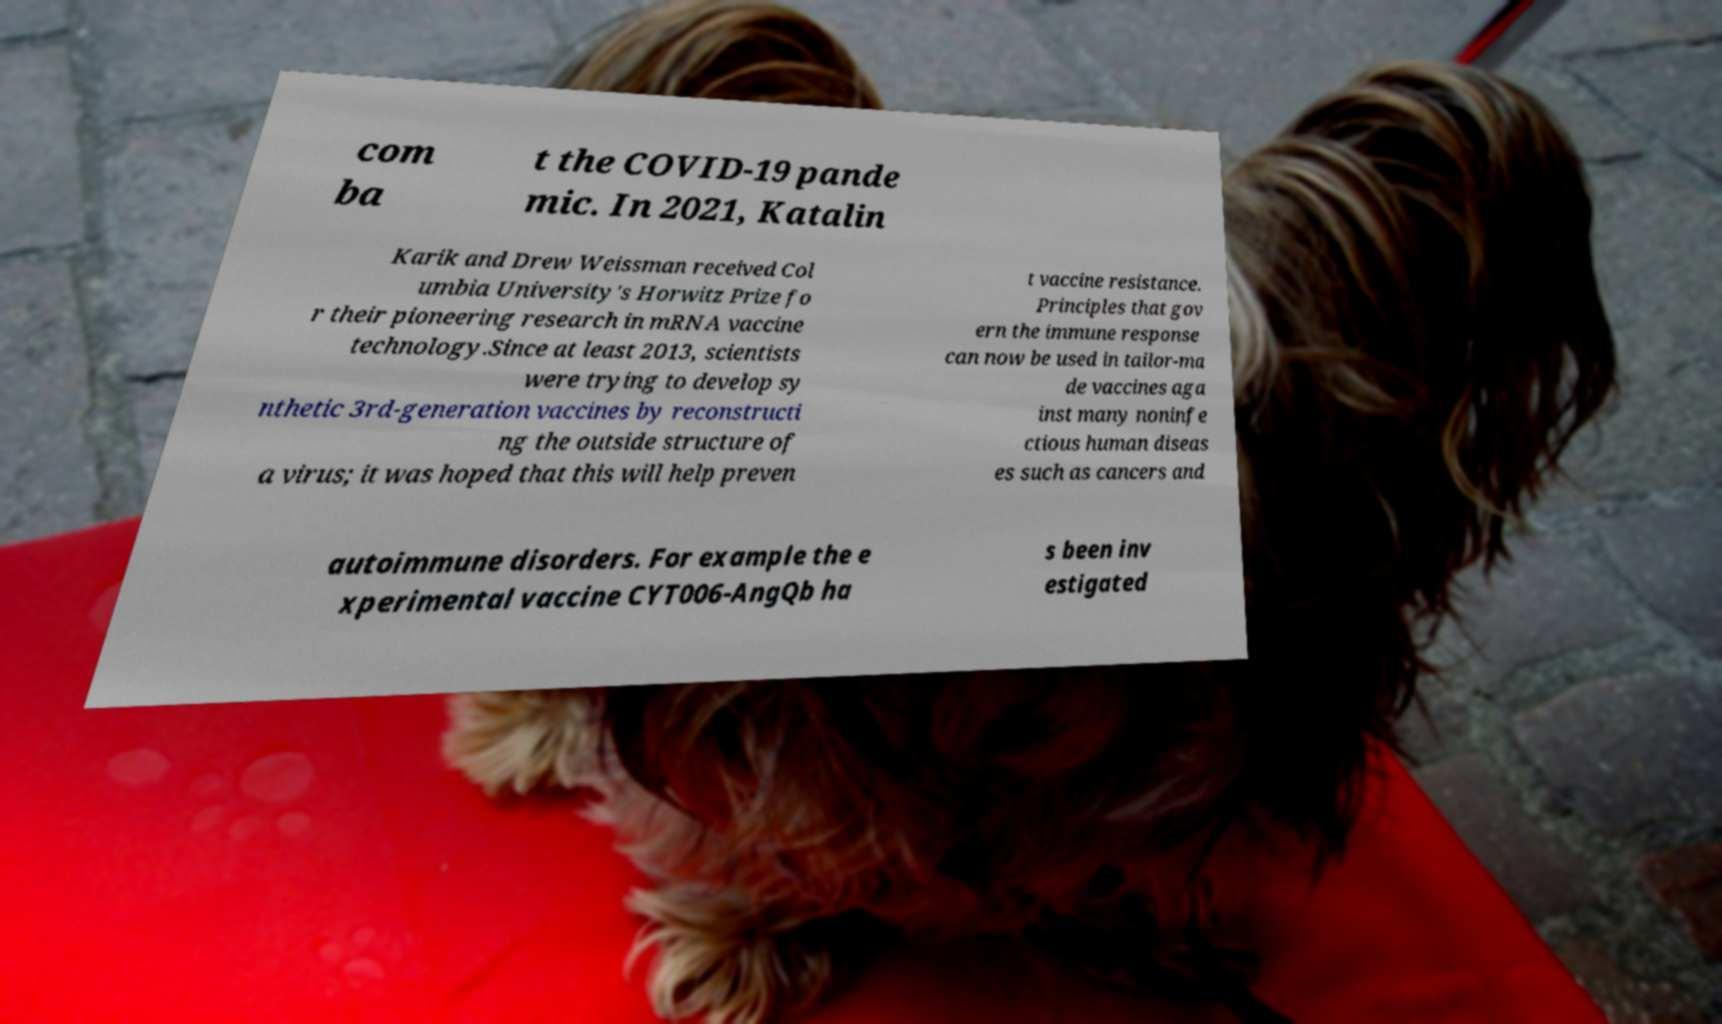Please identify and transcribe the text found in this image. com ba t the COVID-19 pande mic. In 2021, Katalin Karik and Drew Weissman received Col umbia University's Horwitz Prize fo r their pioneering research in mRNA vaccine technology.Since at least 2013, scientists were trying to develop sy nthetic 3rd-generation vaccines by reconstructi ng the outside structure of a virus; it was hoped that this will help preven t vaccine resistance. Principles that gov ern the immune response can now be used in tailor-ma de vaccines aga inst many noninfe ctious human diseas es such as cancers and autoimmune disorders. For example the e xperimental vaccine CYT006-AngQb ha s been inv estigated 